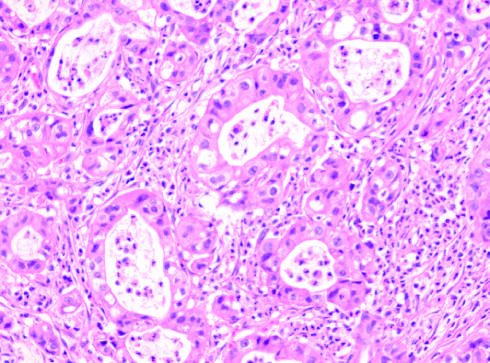does the tumor have the same appearance as that of intrahepatic cholangiocarcinoma?
Answer the question using a single word or phrase. Yes 